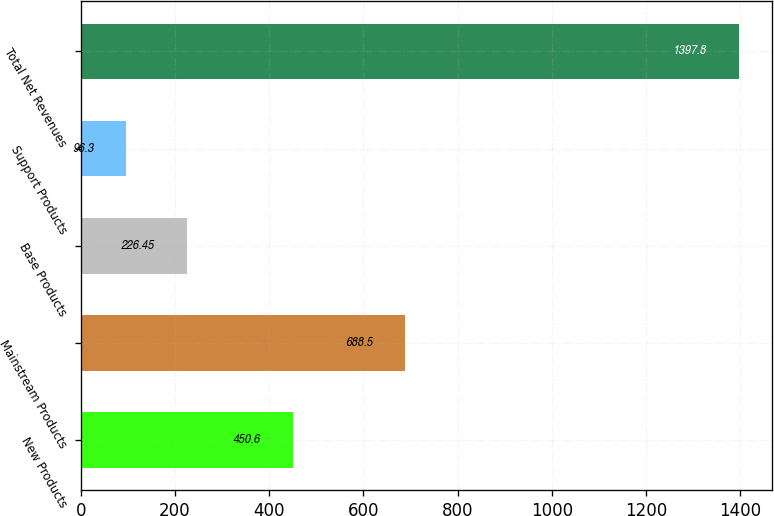<chart> <loc_0><loc_0><loc_500><loc_500><bar_chart><fcel>New Products<fcel>Mainstream Products<fcel>Base Products<fcel>Support Products<fcel>Total Net Revenues<nl><fcel>450.6<fcel>688.5<fcel>226.45<fcel>96.3<fcel>1397.8<nl></chart> 